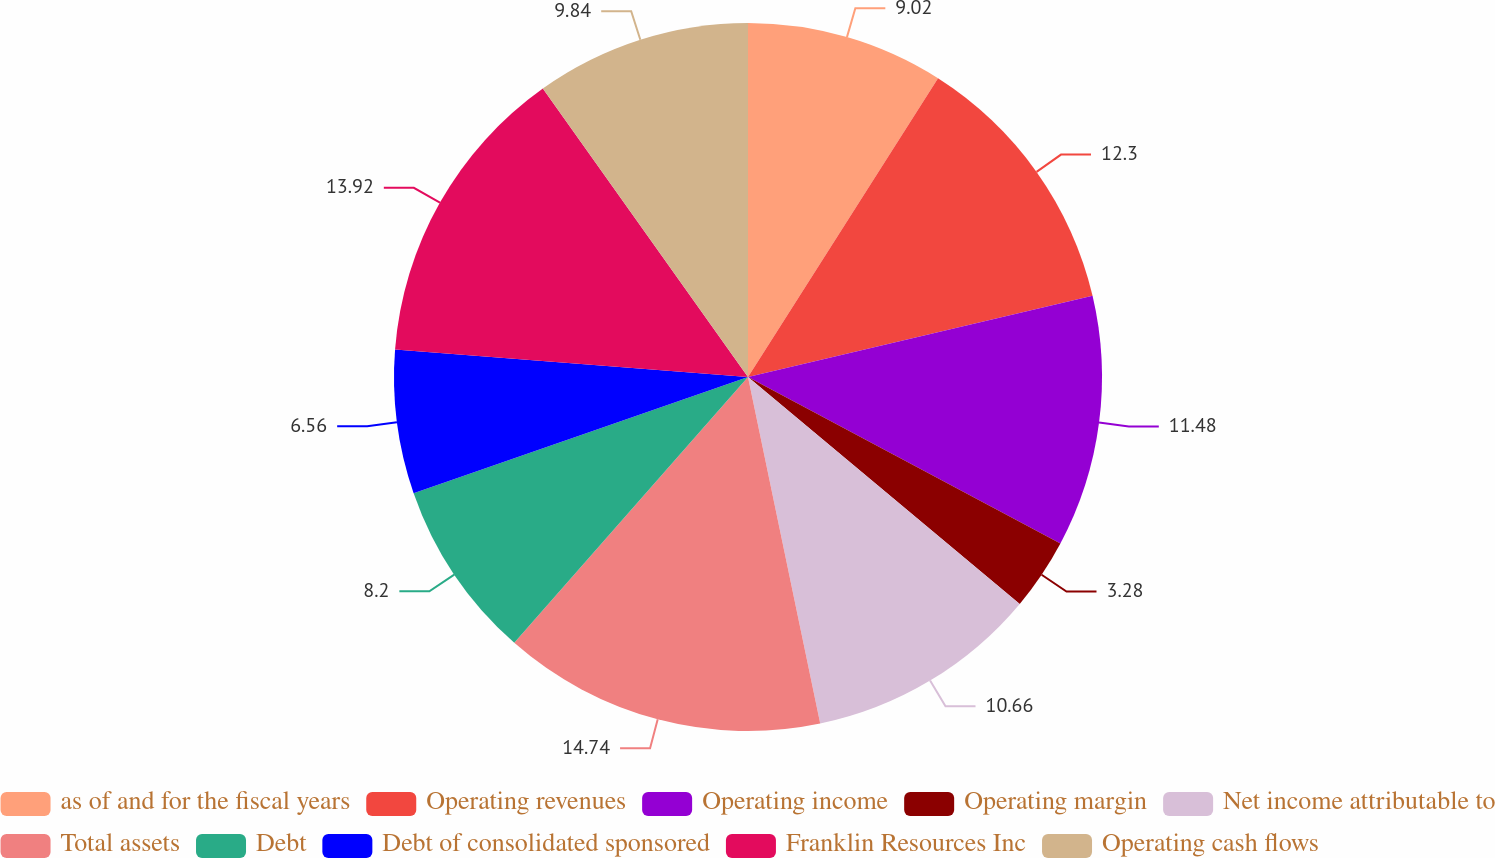Convert chart. <chart><loc_0><loc_0><loc_500><loc_500><pie_chart><fcel>as of and for the fiscal years<fcel>Operating revenues<fcel>Operating income<fcel>Operating margin<fcel>Net income attributable to<fcel>Total assets<fcel>Debt<fcel>Debt of consolidated sponsored<fcel>Franklin Resources Inc<fcel>Operating cash flows<nl><fcel>9.02%<fcel>12.3%<fcel>11.48%<fcel>3.28%<fcel>10.66%<fcel>14.75%<fcel>8.2%<fcel>6.56%<fcel>13.93%<fcel>9.84%<nl></chart> 